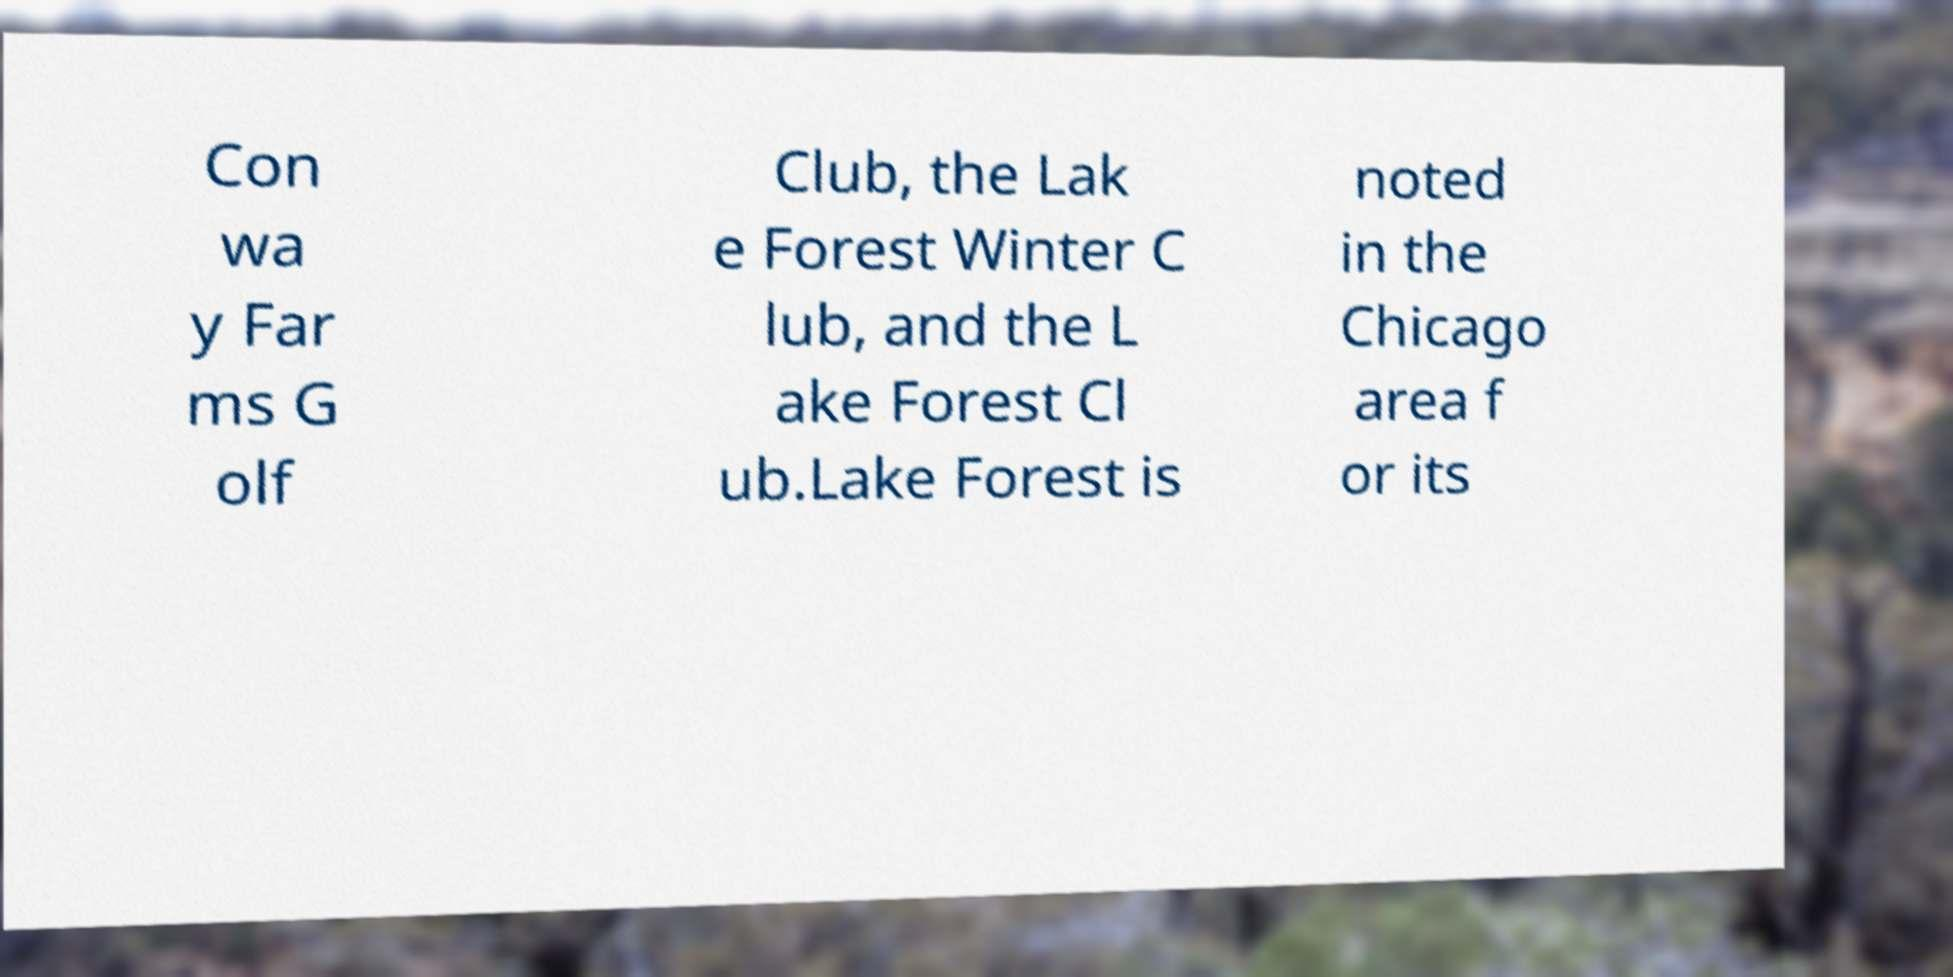Please read and relay the text visible in this image. What does it say? Con wa y Far ms G olf Club, the Lak e Forest Winter C lub, and the L ake Forest Cl ub.Lake Forest is noted in the Chicago area f or its 